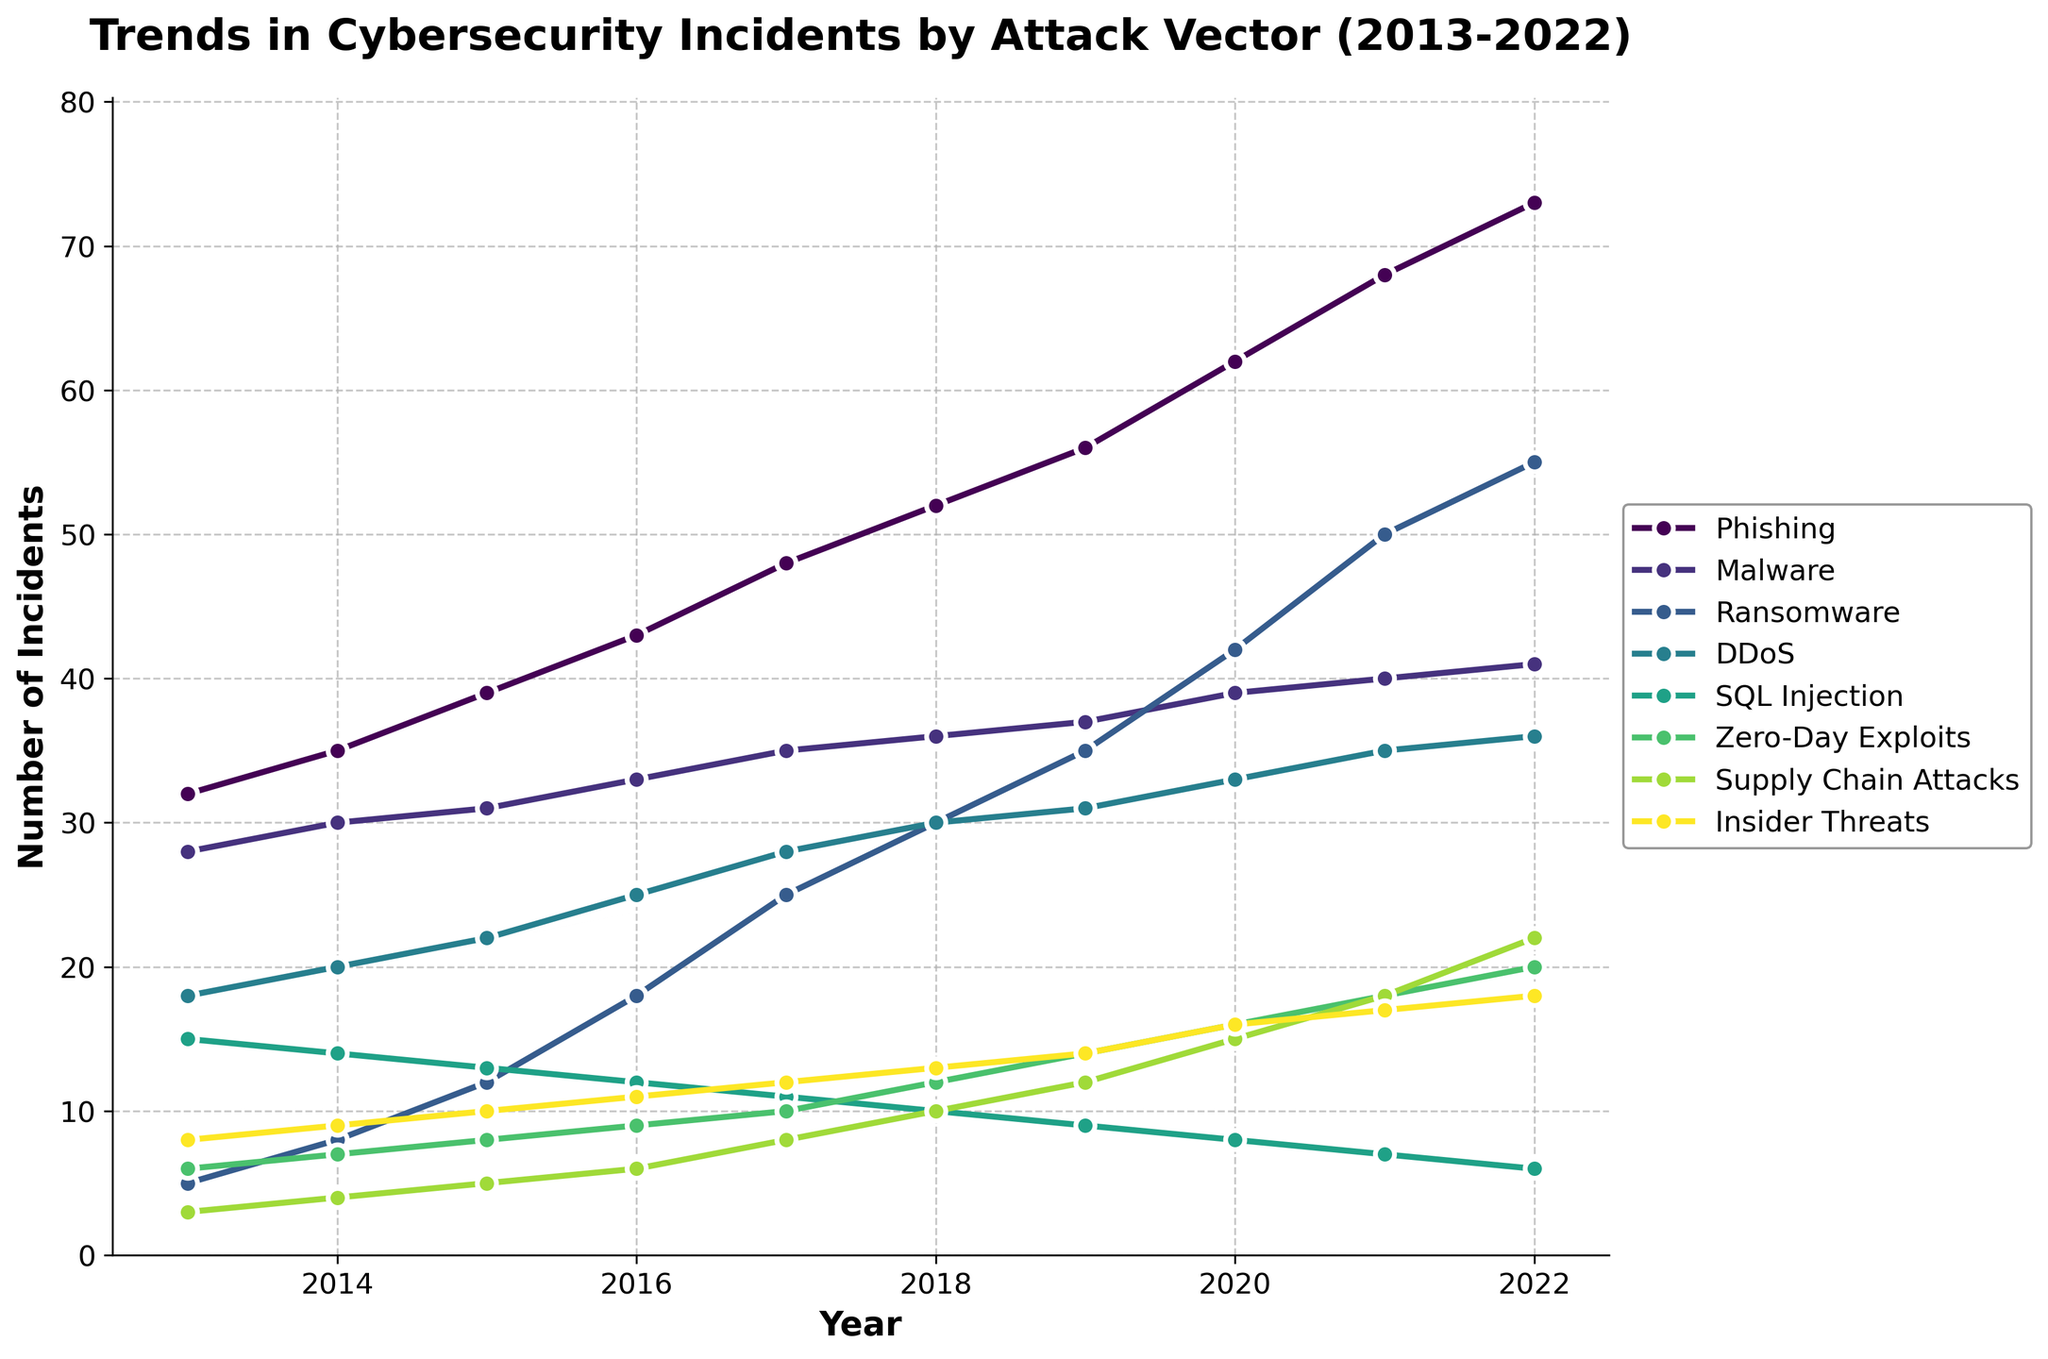What was the highest number of phishing incidents recorded, and in which year did it occur? To find the highest number of phishing incidents, look at the phishing trend line and identify the peak value. The highest number occurred in 2022 with a count of 73.
Answer: 73 in 2022 Between malware and ransomware incidents, which saw a greater increase from 2013 to 2022? Calculate the increase for both: Malware rose from 28 to 41, so the increase is 41 - 28 = 13. Ransomware rose from 5 to 55, so the increase is 55 - 5 = 50. Comparing these, ransomware had a greater increase.
Answer: Ransomware, with an increase of 50 Which attack vector showed a decline in the number of incidents over the past decade? To identify a declining trend, look for a downward sloping line across the years. SQL Injection incidents declined from 15 in 2013 to 6 in 2022.
Answer: SQL Injection In 2020, what was the combined total of incidents for DDoS and Zero-Day Exploits? Locate the values for DDoS and Zero-Day Exploits in 2020. DDoS had 33 incidents and Zero-Day Exploits had 16 incidents. Combined, 33 + 16 = 49.
Answer: 49 Did phishing incidents ever experience a decrease within a year in the period shown? Examine the phishing trend line from 2013 to 2022. The line is consistently rising, indicating no decrease in any year.
Answer: No How many more malware incidents were there compared to insider threats in 2016? Locate the values for both in 2016. Malware had 33 incidents, and insider threats had 11 incidents. The difference is 33 - 11 = 22.
Answer: 22 How did the number of Supply Chain Attacks change from 2018 to 2020? Note the values for Supply Chain Attacks in 2018 and 2020. In 2018, there were 10 incidents, and by 2020, there were 15 incidents, showing an increase of 15 - 10 = 5.
Answer: Increased by 5 Which year saw the highest total number of incidents across all attack vectors? Sum all incidents for each year and compare. 2022 has the highest total with values 73 (Phishing) + 41 (Malware) + 55 (Ransomware) + 36 (DDoS) + 6 (SQL Injection) + 20 (Zero-Day Exploits) + 22 (Supply Chain Attacks) + 18 (Insider Threats) = 271.
Answer: 2022 Which attack vector had the smallest number of incidents in 2014, and how many were there? Identify the lowest point on the chart for 2014. Zero-Day Exploits had the least incidents with a count of 7.
Answer: Zero-Day Exploits, 7 